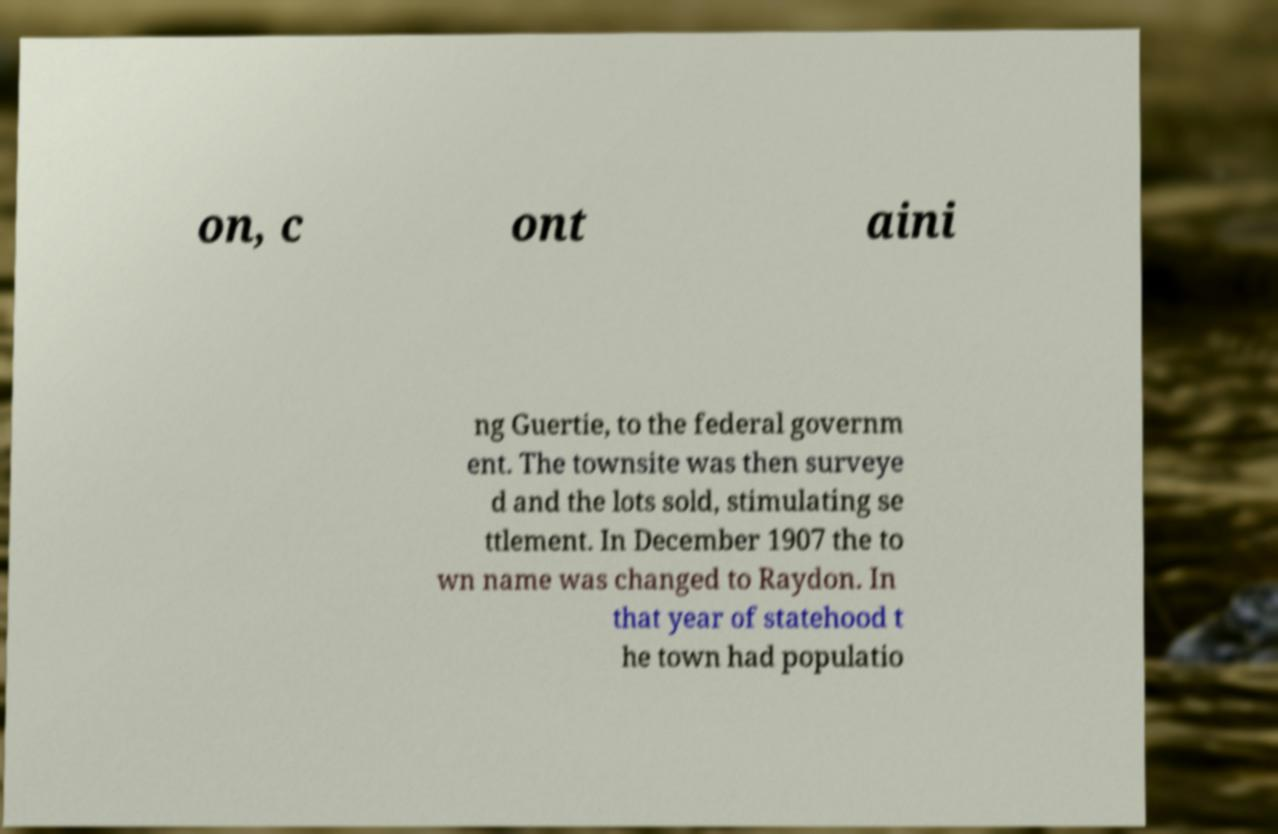What messages or text are displayed in this image? I need them in a readable, typed format. on, c ont aini ng Guertie, to the federal governm ent. The townsite was then surveye d and the lots sold, stimulating se ttlement. In December 1907 the to wn name was changed to Raydon. In that year of statehood t he town had populatio 